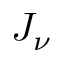<formula> <loc_0><loc_0><loc_500><loc_500>J _ { \nu }</formula> 